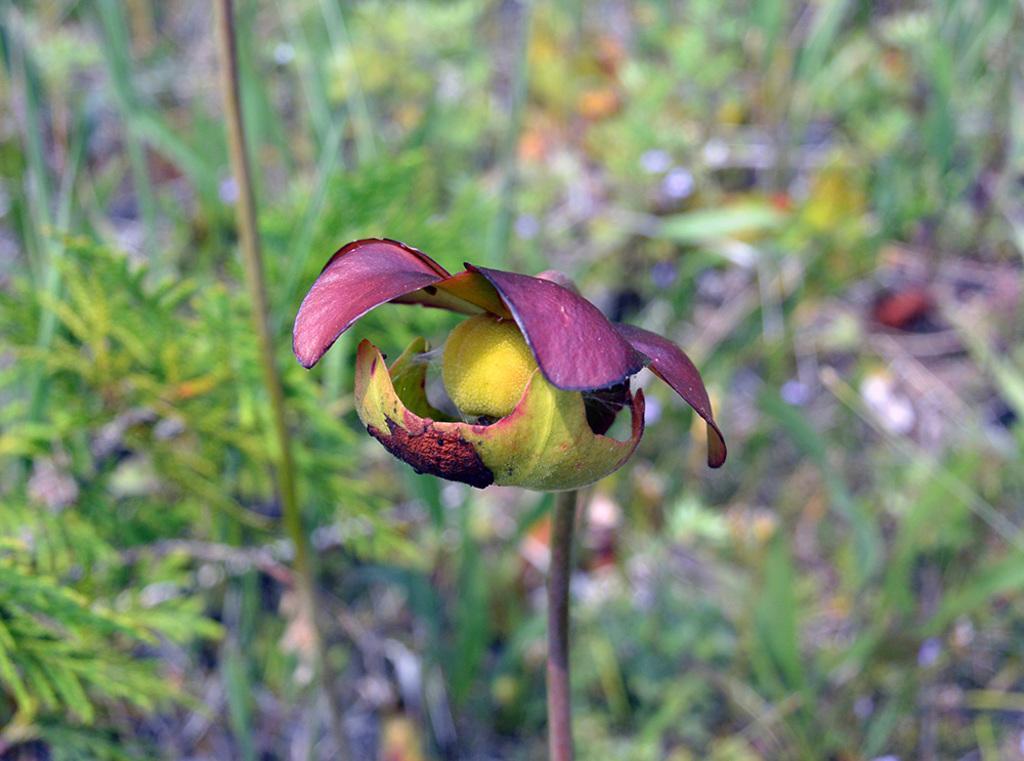Describe this image in one or two sentences. In this image I can see a flower and I can see grass and stem of the plant. 